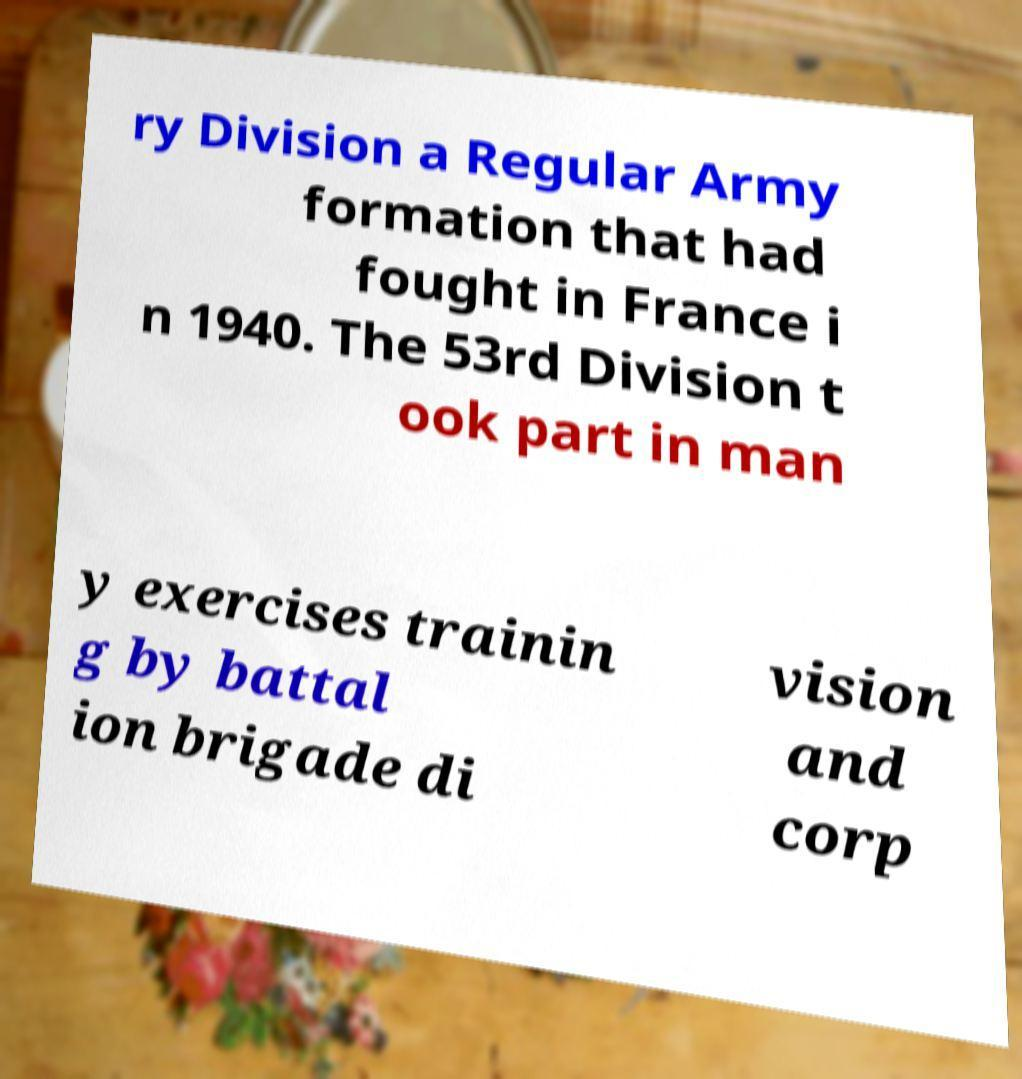There's text embedded in this image that I need extracted. Can you transcribe it verbatim? ry Division a Regular Army formation that had fought in France i n 1940. The 53rd Division t ook part in man y exercises trainin g by battal ion brigade di vision and corp 